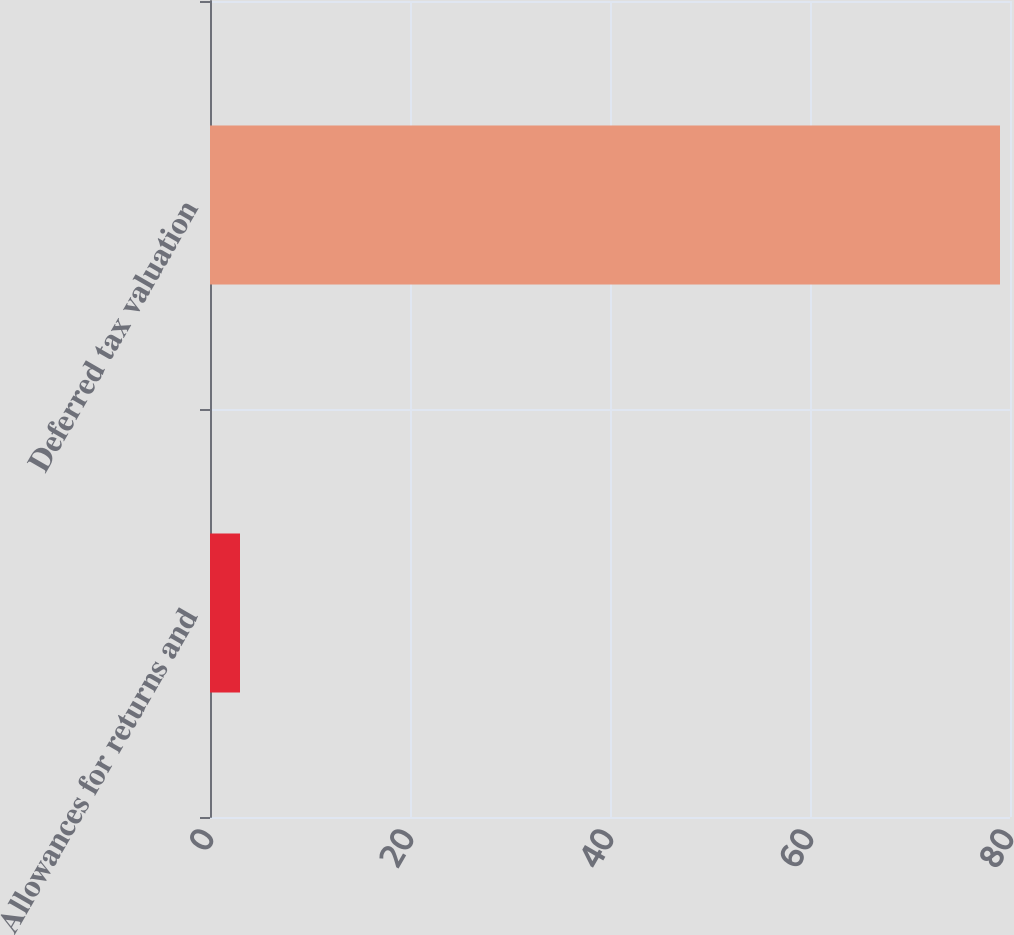Convert chart. <chart><loc_0><loc_0><loc_500><loc_500><bar_chart><fcel>Allowances for returns and<fcel>Deferred tax valuation<nl><fcel>3<fcel>79<nl></chart> 